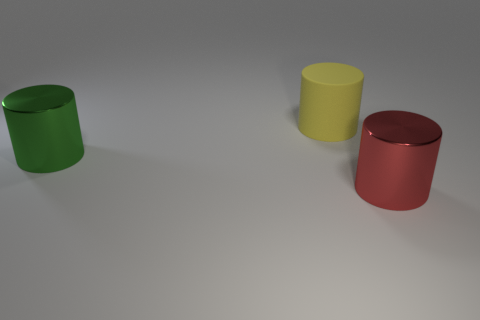Subtract all large yellow cylinders. How many cylinders are left? 2 Subtract all green cylinders. How many cylinders are left? 2 Subtract 2 cylinders. How many cylinders are left? 1 Add 2 big red metal things. How many big red metal things exist? 3 Add 1 small brown metal cylinders. How many objects exist? 4 Subtract 0 blue cubes. How many objects are left? 3 Subtract all blue cylinders. Subtract all gray blocks. How many cylinders are left? 3 Subtract all red cubes. How many red cylinders are left? 1 Subtract all large matte cylinders. Subtract all metal objects. How many objects are left? 0 Add 2 rubber things. How many rubber things are left? 3 